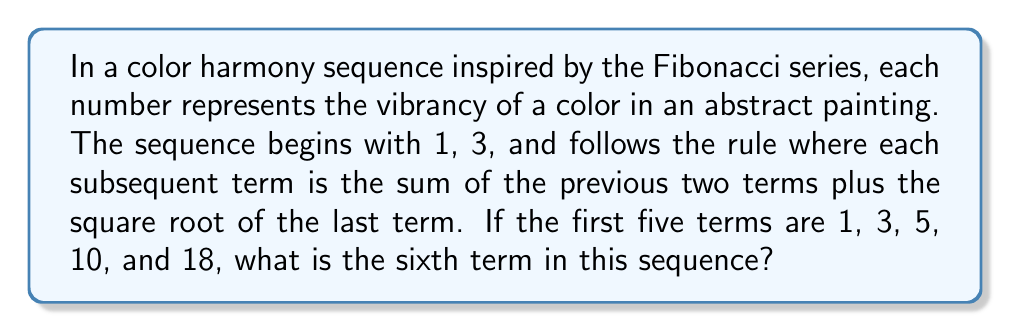Solve this math problem. Let's approach this step-by-step:

1. First, let's observe the given sequence: 1, 3, 5, 10, 18

2. We're told that each term after the first two is the sum of the previous two terms plus the square root of the last term.

3. Let's verify this for the given terms:
   - For the 3rd term: $5 = 1 + 3 + \sqrt{3} \approx 5.73$ (rounded down to 5)
   - For the 4th term: $10 = 3 + 5 + \sqrt{5} \approx 10.24$ (rounded down to 10)
   - For the 5th term: $18 = 5 + 10 + \sqrt{10} \approx 18.16$ (rounded down to 18)

4. To find the 6th term, we'll use the same rule:
   6th term $= 10 + 18 + \sqrt{18}$

5. Calculating:
   $10 + 18 = 28$
   $\sqrt{18} \approx 4.24$

6. Adding these together:
   $28 + 4.24 \approx 32.24$

7. Rounding down to the nearest whole number (as done in previous terms):
   6th term $= 32$

This sequence mimics the Fibonacci series but adds an element of color theory, where the square root could represent a harmonic overtone in the color palette, creating a unique mathematical representation of color harmony in abstract art.
Answer: 32 